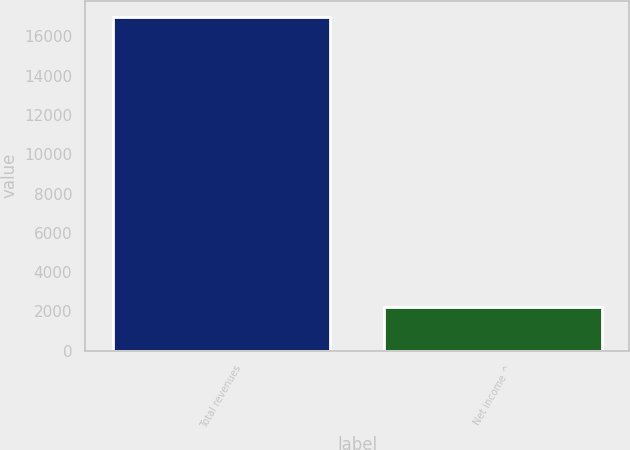<chart> <loc_0><loc_0><loc_500><loc_500><bar_chart><fcel>Total revenues<fcel>Net income ^<nl><fcel>16962<fcel>2231<nl></chart> 